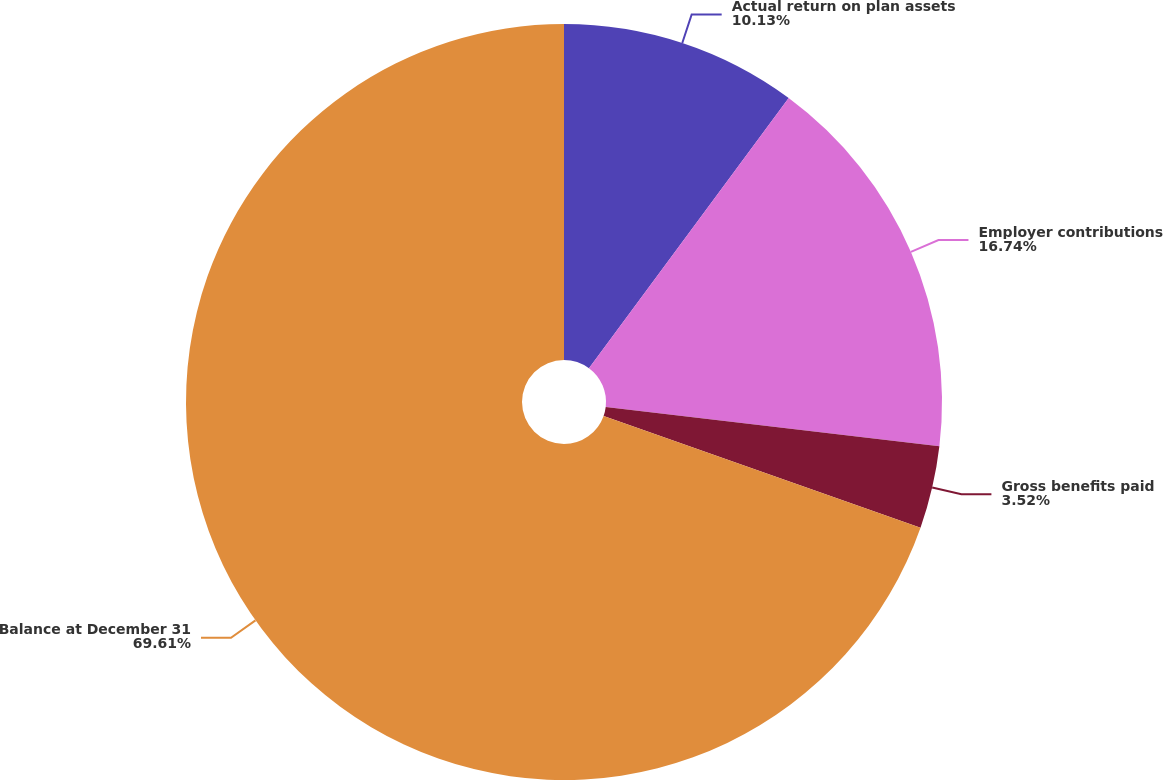Convert chart. <chart><loc_0><loc_0><loc_500><loc_500><pie_chart><fcel>Actual return on plan assets<fcel>Employer contributions<fcel>Gross benefits paid<fcel>Balance at December 31<nl><fcel>10.13%<fcel>16.74%<fcel>3.52%<fcel>69.6%<nl></chart> 